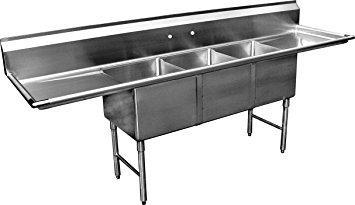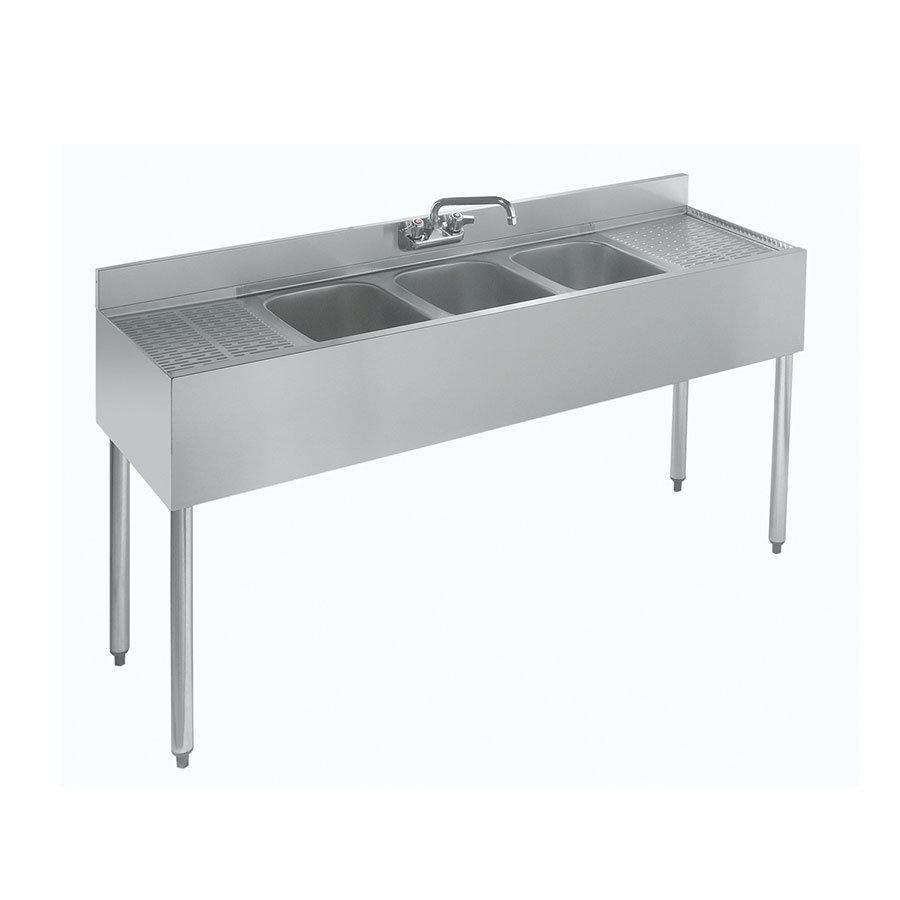The first image is the image on the left, the second image is the image on the right. For the images displayed, is the sentence "Each image contains a three part sink without a faucet" factually correct? Answer yes or no. No. The first image is the image on the left, the second image is the image on the right. For the images displayed, is the sentence "In at least one image there is a three basin sink with a a long left washing counter." factually correct? Answer yes or no. Yes. 